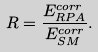Convert formula to latex. <formula><loc_0><loc_0><loc_500><loc_500>R = \frac { E ^ { c o r r } _ { R P A } } { E ^ { c o r r } _ { S M } } .</formula> 